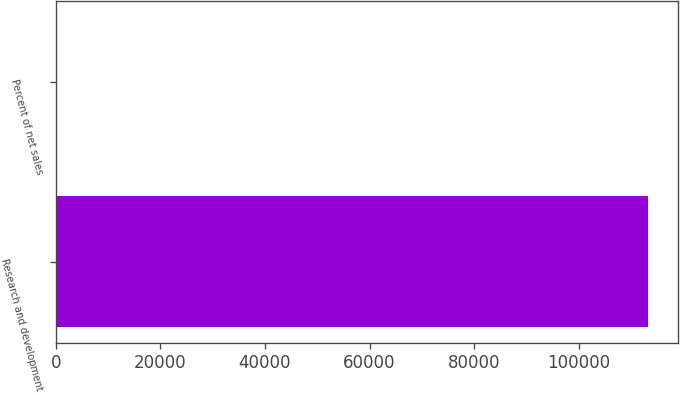Convert chart. <chart><loc_0><loc_0><loc_500><loc_500><bar_chart><fcel>Research and development<fcel>Percent of net sales<nl><fcel>113314<fcel>6.4<nl></chart> 